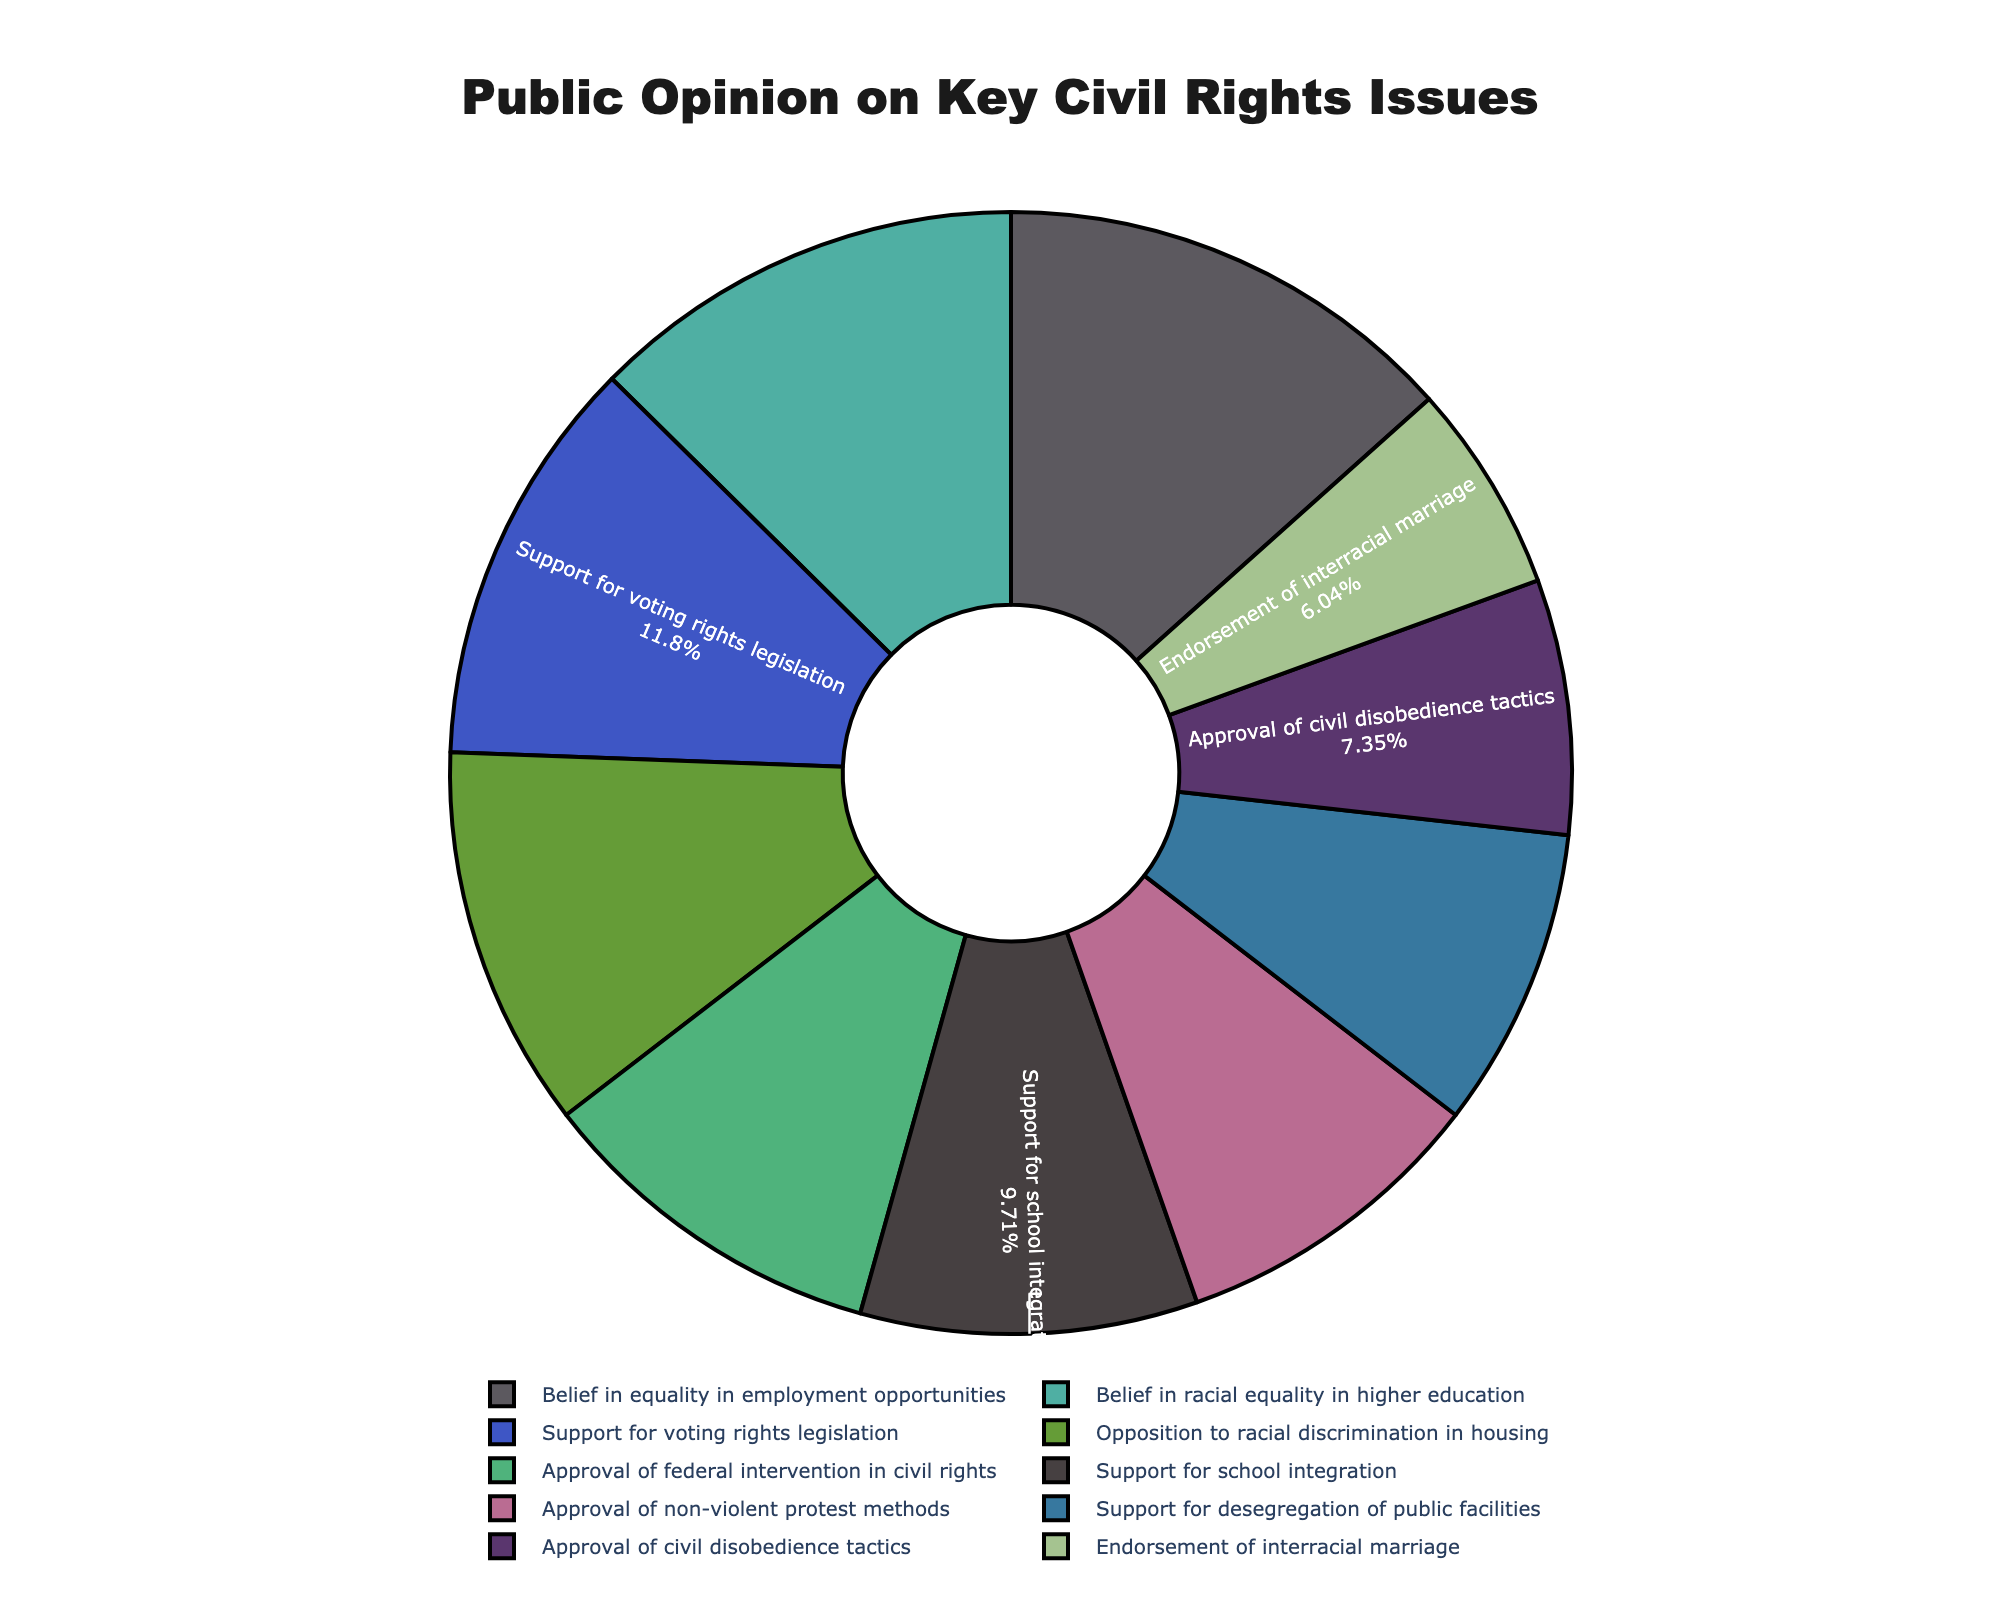What civil rights issue has the highest level of support according to the chart? To find the civil rights issue with the highest level of support, identify the slice with the largest percentage. Here, "Belief in equality in employment opportunities" has the highest percentage at 51%.
Answer: Belief in equality in employment opportunities Which issue garners more support, endorsement of interracial marriage or support for desegregation of public facilities? To compare the support levels, look at the percentages for both topics. Endorsement of interracial marriage has 23%, while support for desegregation of public facilities has 33%. Therefore, desegregation of public facilities has more support.
Answer: Support for desegregation of public facilities What is the average percentage for the support of civil rights issues mentioned? To find the average percentage, sum up all the percentages and divide by the number of issues. The sum is 37 + 42 + 28 + 45 + 51 + 23 + 39 + 33 + 48 + 35 = 381. There are 10 issues. So, the average is 381/10 = 38.1%.
Answer: 38.1% What is the difference in support between approval of federal intervention in civil rights and opposition to racial discrimination in housing? To find the difference, subtract the smaller percentage from the larger one. Approval of federal intervention in civil rights has 39%, and opposition to racial discrimination in housing has 42%. The difference is 42 - 39 = 3%.
Answer: 3% If you combine support for school integration and support for voting rights legislation, what is the total percentage? Add the percentages for support for school integration (37%) and support for voting rights legislation (45%). The total is 37 + 45 = 82%.
Answer: 82% Which issue has a closely similar level of support to approval of non-violent protest methods? To find the closest similar percentage to approval of non-violent protest methods (35%), compare it to other percentages. Support for school integration (37%) is the closest.
Answer: Support for school integration How many issues have a support level higher than 40%? Identify issues with percentages over 40%. These are: Opposition to racial discrimination in housing (42%), Support for voting rights legislation (45%), Belief in equality in employment opportunities (51%), and Belief in racial equality in higher education (48%). There are 4 issues.
Answer: 4 Which civil rights issue appears in a color that seems predominantly blue in the chart? Visually identify the issue represented by the mostly blue-colored slice. This varies based on the random colors but assume it is Belief in racial equality in higher education (48%) for this example.
Answer: Belief in racial equality in higher education What is the combined percentage of issues with support levels below 30%? Identify and sum the percentages of issues with support below 30%: Approval of civil disobedience tactics (28%) and Endorsement of interracial marriage (23%). The total is 28 + 23 = 51%.
Answer: 51% Which issue has more support: approval of civil disobedience tactics or approval of non-violent protest methods? Compare the percentages: Approval of civil disobedience tactics has 28%, and approval of non-violent protest methods has 35%. Therefore, non-violent protest methods have more support.
Answer: Approval of non-violent protest methods 